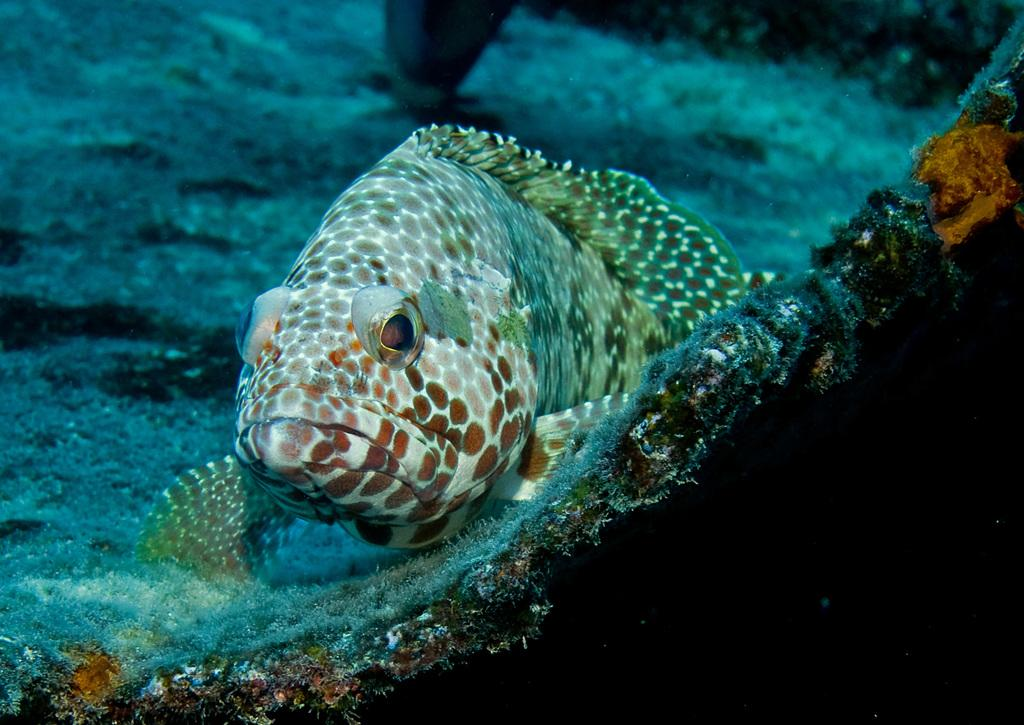What type of animal can be seen in the image? There is a fish in the water. What can be seen in the background of the image? There are reefs in the background of the image. What type of winter clothing is the fish wearing in the image? There is no winter clothing present in the image, as it features a fish in the water with reefs in the background. 